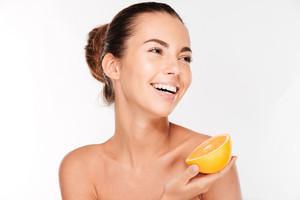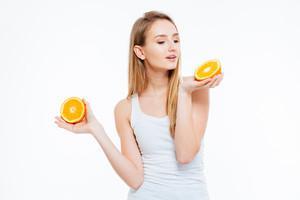The first image is the image on the left, the second image is the image on the right. Analyze the images presented: Is the assertion "In one image, a woman is holding one or more slices of orange to her face, while a child in a second image is holding up an orange or part of one in each hand." valid? Answer yes or no. No. The first image is the image on the left, the second image is the image on the right. Examine the images to the left and right. Is the description "One person is holding an orange slice over at least one of their eyes." accurate? Answer yes or no. No. 